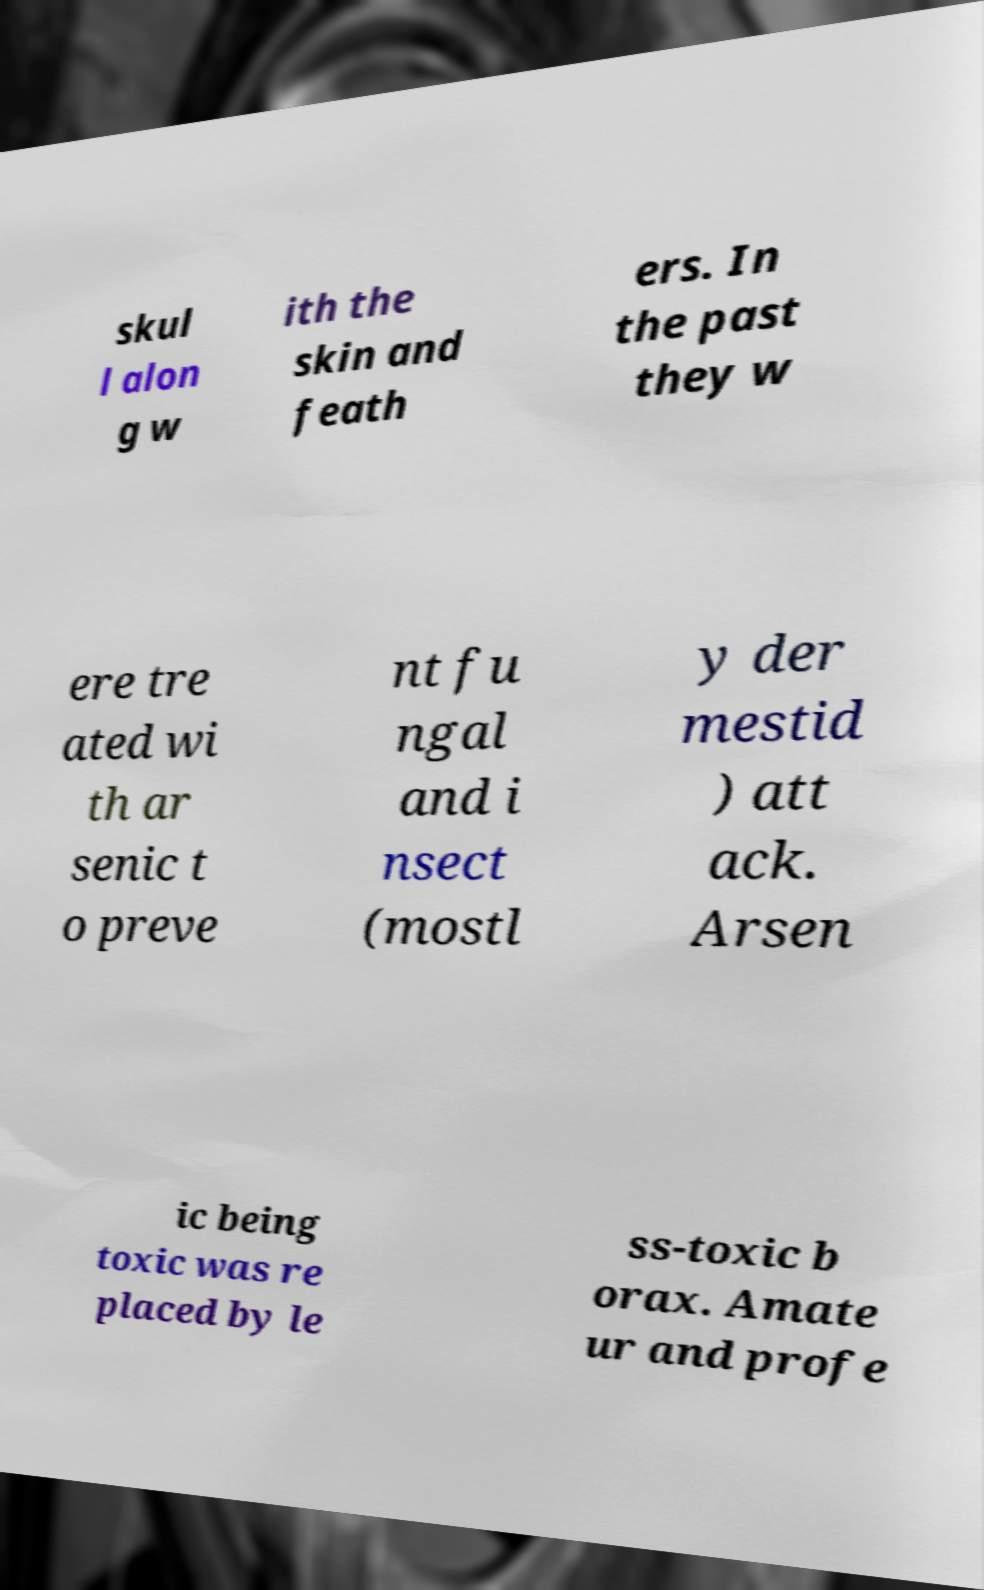Please read and relay the text visible in this image. What does it say? skul l alon g w ith the skin and feath ers. In the past they w ere tre ated wi th ar senic t o preve nt fu ngal and i nsect (mostl y der mestid ) att ack. Arsen ic being toxic was re placed by le ss-toxic b orax. Amate ur and profe 